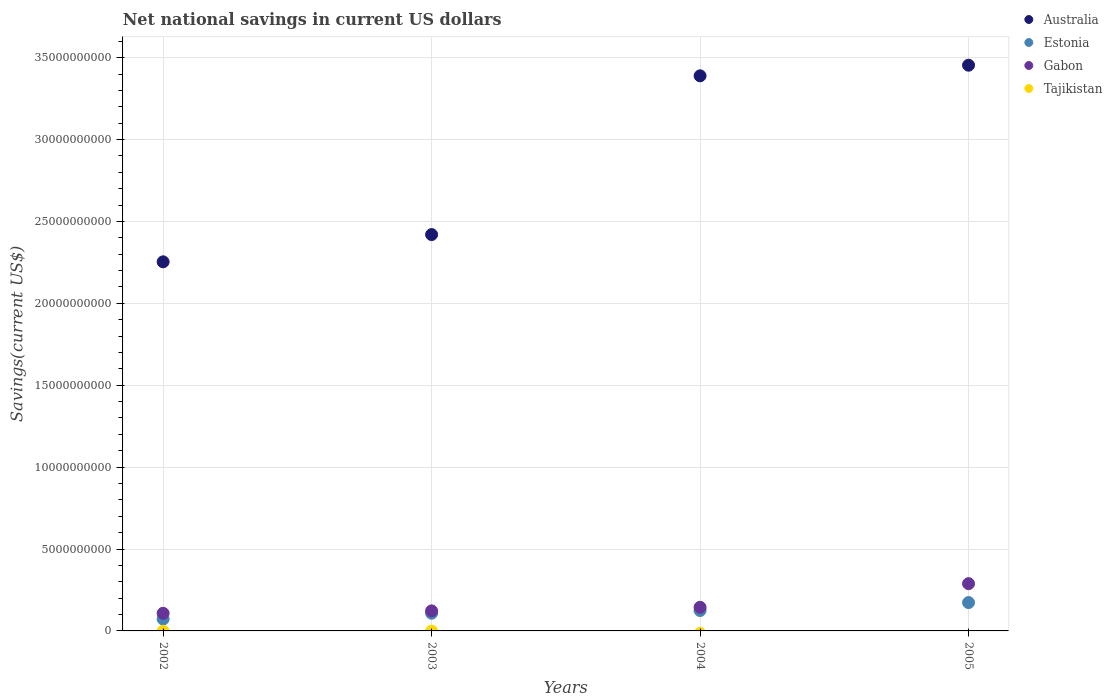Is the number of dotlines equal to the number of legend labels?
Provide a short and direct response. No. Across all years, what is the maximum net national savings in Australia?
Make the answer very short. 3.45e+1. Across all years, what is the minimum net national savings in Estonia?
Keep it short and to the point. 7.23e+08. In which year was the net national savings in Gabon maximum?
Ensure brevity in your answer.  2005. What is the total net national savings in Estonia in the graph?
Provide a succinct answer. 4.78e+09. What is the difference between the net national savings in Australia in 2002 and that in 2004?
Make the answer very short. -1.14e+1. What is the difference between the net national savings in Gabon in 2004 and the net national savings in Australia in 2003?
Your response must be concise. -2.28e+1. In the year 2002, what is the difference between the net national savings in Gabon and net national savings in Estonia?
Provide a short and direct response. 3.52e+08. What is the ratio of the net national savings in Gabon in 2003 to that in 2005?
Your answer should be very brief. 0.42. Is the net national savings in Gabon in 2002 less than that in 2003?
Offer a very short reply. Yes. Is the difference between the net national savings in Gabon in 2002 and 2004 greater than the difference between the net national savings in Estonia in 2002 and 2004?
Your answer should be compact. Yes. What is the difference between the highest and the second highest net national savings in Australia?
Provide a short and direct response. 6.49e+08. What is the difference between the highest and the lowest net national savings in Gabon?
Ensure brevity in your answer.  1.81e+09. Does the net national savings in Tajikistan monotonically increase over the years?
Give a very brief answer. No. Is the net national savings in Estonia strictly greater than the net national savings in Tajikistan over the years?
Your answer should be very brief. Yes. How many dotlines are there?
Give a very brief answer. 3. What is the difference between two consecutive major ticks on the Y-axis?
Your answer should be very brief. 5.00e+09. How many legend labels are there?
Your answer should be very brief. 4. What is the title of the graph?
Keep it short and to the point. Net national savings in current US dollars. What is the label or title of the X-axis?
Keep it short and to the point. Years. What is the label or title of the Y-axis?
Offer a terse response. Savings(current US$). What is the Savings(current US$) in Australia in 2002?
Make the answer very short. 2.25e+1. What is the Savings(current US$) of Estonia in 2002?
Make the answer very short. 7.23e+08. What is the Savings(current US$) of Gabon in 2002?
Provide a succinct answer. 1.08e+09. What is the Savings(current US$) in Tajikistan in 2002?
Offer a very short reply. 0. What is the Savings(current US$) in Australia in 2003?
Your answer should be very brief. 2.42e+1. What is the Savings(current US$) of Estonia in 2003?
Give a very brief answer. 1.08e+09. What is the Savings(current US$) of Gabon in 2003?
Make the answer very short. 1.22e+09. What is the Savings(current US$) of Australia in 2004?
Your response must be concise. 3.39e+1. What is the Savings(current US$) in Estonia in 2004?
Give a very brief answer. 1.25e+09. What is the Savings(current US$) of Gabon in 2004?
Give a very brief answer. 1.44e+09. What is the Savings(current US$) of Australia in 2005?
Provide a succinct answer. 3.45e+1. What is the Savings(current US$) in Estonia in 2005?
Offer a very short reply. 1.73e+09. What is the Savings(current US$) in Gabon in 2005?
Offer a terse response. 2.89e+09. What is the Savings(current US$) in Tajikistan in 2005?
Your answer should be compact. 0. Across all years, what is the maximum Savings(current US$) of Australia?
Keep it short and to the point. 3.45e+1. Across all years, what is the maximum Savings(current US$) in Estonia?
Your response must be concise. 1.73e+09. Across all years, what is the maximum Savings(current US$) of Gabon?
Offer a very short reply. 2.89e+09. Across all years, what is the minimum Savings(current US$) of Australia?
Make the answer very short. 2.25e+1. Across all years, what is the minimum Savings(current US$) of Estonia?
Provide a succinct answer. 7.23e+08. Across all years, what is the minimum Savings(current US$) in Gabon?
Ensure brevity in your answer.  1.08e+09. What is the total Savings(current US$) of Australia in the graph?
Provide a succinct answer. 1.15e+11. What is the total Savings(current US$) in Estonia in the graph?
Offer a very short reply. 4.78e+09. What is the total Savings(current US$) in Gabon in the graph?
Offer a terse response. 6.63e+09. What is the difference between the Savings(current US$) in Australia in 2002 and that in 2003?
Give a very brief answer. -1.66e+09. What is the difference between the Savings(current US$) of Estonia in 2002 and that in 2003?
Give a very brief answer. -3.56e+08. What is the difference between the Savings(current US$) of Gabon in 2002 and that in 2003?
Provide a succinct answer. -1.48e+08. What is the difference between the Savings(current US$) in Australia in 2002 and that in 2004?
Offer a very short reply. -1.14e+1. What is the difference between the Savings(current US$) of Estonia in 2002 and that in 2004?
Your answer should be very brief. -5.23e+08. What is the difference between the Savings(current US$) in Gabon in 2002 and that in 2004?
Ensure brevity in your answer.  -3.68e+08. What is the difference between the Savings(current US$) in Australia in 2002 and that in 2005?
Offer a very short reply. -1.20e+1. What is the difference between the Savings(current US$) of Estonia in 2002 and that in 2005?
Your response must be concise. -1.01e+09. What is the difference between the Savings(current US$) of Gabon in 2002 and that in 2005?
Your answer should be compact. -1.81e+09. What is the difference between the Savings(current US$) in Australia in 2003 and that in 2004?
Your answer should be compact. -9.69e+09. What is the difference between the Savings(current US$) of Estonia in 2003 and that in 2004?
Provide a succinct answer. -1.67e+08. What is the difference between the Savings(current US$) in Gabon in 2003 and that in 2004?
Your response must be concise. -2.20e+08. What is the difference between the Savings(current US$) in Australia in 2003 and that in 2005?
Provide a succinct answer. -1.03e+1. What is the difference between the Savings(current US$) of Estonia in 2003 and that in 2005?
Your answer should be compact. -6.51e+08. What is the difference between the Savings(current US$) of Gabon in 2003 and that in 2005?
Ensure brevity in your answer.  -1.66e+09. What is the difference between the Savings(current US$) of Australia in 2004 and that in 2005?
Provide a succinct answer. -6.49e+08. What is the difference between the Savings(current US$) of Estonia in 2004 and that in 2005?
Your answer should be very brief. -4.84e+08. What is the difference between the Savings(current US$) in Gabon in 2004 and that in 2005?
Your answer should be very brief. -1.44e+09. What is the difference between the Savings(current US$) in Australia in 2002 and the Savings(current US$) in Estonia in 2003?
Offer a very short reply. 2.15e+1. What is the difference between the Savings(current US$) in Australia in 2002 and the Savings(current US$) in Gabon in 2003?
Make the answer very short. 2.13e+1. What is the difference between the Savings(current US$) of Estonia in 2002 and the Savings(current US$) of Gabon in 2003?
Keep it short and to the point. -5.00e+08. What is the difference between the Savings(current US$) in Australia in 2002 and the Savings(current US$) in Estonia in 2004?
Offer a terse response. 2.13e+1. What is the difference between the Savings(current US$) in Australia in 2002 and the Savings(current US$) in Gabon in 2004?
Ensure brevity in your answer.  2.11e+1. What is the difference between the Savings(current US$) in Estonia in 2002 and the Savings(current US$) in Gabon in 2004?
Keep it short and to the point. -7.20e+08. What is the difference between the Savings(current US$) in Australia in 2002 and the Savings(current US$) in Estonia in 2005?
Ensure brevity in your answer.  2.08e+1. What is the difference between the Savings(current US$) of Australia in 2002 and the Savings(current US$) of Gabon in 2005?
Provide a succinct answer. 1.96e+1. What is the difference between the Savings(current US$) in Estonia in 2002 and the Savings(current US$) in Gabon in 2005?
Your answer should be very brief. -2.16e+09. What is the difference between the Savings(current US$) of Australia in 2003 and the Savings(current US$) of Estonia in 2004?
Give a very brief answer. 2.30e+1. What is the difference between the Savings(current US$) of Australia in 2003 and the Savings(current US$) of Gabon in 2004?
Provide a succinct answer. 2.28e+1. What is the difference between the Savings(current US$) in Estonia in 2003 and the Savings(current US$) in Gabon in 2004?
Offer a terse response. -3.64e+08. What is the difference between the Savings(current US$) in Australia in 2003 and the Savings(current US$) in Estonia in 2005?
Keep it short and to the point. 2.25e+1. What is the difference between the Savings(current US$) of Australia in 2003 and the Savings(current US$) of Gabon in 2005?
Offer a very short reply. 2.13e+1. What is the difference between the Savings(current US$) of Estonia in 2003 and the Savings(current US$) of Gabon in 2005?
Make the answer very short. -1.81e+09. What is the difference between the Savings(current US$) in Australia in 2004 and the Savings(current US$) in Estonia in 2005?
Keep it short and to the point. 3.22e+1. What is the difference between the Savings(current US$) in Australia in 2004 and the Savings(current US$) in Gabon in 2005?
Your answer should be very brief. 3.10e+1. What is the difference between the Savings(current US$) in Estonia in 2004 and the Savings(current US$) in Gabon in 2005?
Your answer should be compact. -1.64e+09. What is the average Savings(current US$) in Australia per year?
Your answer should be very brief. 2.88e+1. What is the average Savings(current US$) in Estonia per year?
Make the answer very short. 1.20e+09. What is the average Savings(current US$) in Gabon per year?
Make the answer very short. 1.66e+09. In the year 2002, what is the difference between the Savings(current US$) in Australia and Savings(current US$) in Estonia?
Offer a very short reply. 2.18e+1. In the year 2002, what is the difference between the Savings(current US$) of Australia and Savings(current US$) of Gabon?
Keep it short and to the point. 2.15e+1. In the year 2002, what is the difference between the Savings(current US$) of Estonia and Savings(current US$) of Gabon?
Ensure brevity in your answer.  -3.52e+08. In the year 2003, what is the difference between the Savings(current US$) in Australia and Savings(current US$) in Estonia?
Offer a very short reply. 2.31e+1. In the year 2003, what is the difference between the Savings(current US$) of Australia and Savings(current US$) of Gabon?
Your answer should be compact. 2.30e+1. In the year 2003, what is the difference between the Savings(current US$) in Estonia and Savings(current US$) in Gabon?
Ensure brevity in your answer.  -1.44e+08. In the year 2004, what is the difference between the Savings(current US$) in Australia and Savings(current US$) in Estonia?
Provide a short and direct response. 3.26e+1. In the year 2004, what is the difference between the Savings(current US$) in Australia and Savings(current US$) in Gabon?
Offer a terse response. 3.24e+1. In the year 2004, what is the difference between the Savings(current US$) in Estonia and Savings(current US$) in Gabon?
Offer a terse response. -1.97e+08. In the year 2005, what is the difference between the Savings(current US$) of Australia and Savings(current US$) of Estonia?
Offer a terse response. 3.28e+1. In the year 2005, what is the difference between the Savings(current US$) of Australia and Savings(current US$) of Gabon?
Provide a succinct answer. 3.17e+1. In the year 2005, what is the difference between the Savings(current US$) in Estonia and Savings(current US$) in Gabon?
Your response must be concise. -1.15e+09. What is the ratio of the Savings(current US$) in Australia in 2002 to that in 2003?
Provide a succinct answer. 0.93. What is the ratio of the Savings(current US$) in Estonia in 2002 to that in 2003?
Offer a terse response. 0.67. What is the ratio of the Savings(current US$) in Gabon in 2002 to that in 2003?
Ensure brevity in your answer.  0.88. What is the ratio of the Savings(current US$) in Australia in 2002 to that in 2004?
Provide a succinct answer. 0.66. What is the ratio of the Savings(current US$) of Estonia in 2002 to that in 2004?
Your answer should be very brief. 0.58. What is the ratio of the Savings(current US$) of Gabon in 2002 to that in 2004?
Provide a succinct answer. 0.75. What is the ratio of the Savings(current US$) of Australia in 2002 to that in 2005?
Provide a short and direct response. 0.65. What is the ratio of the Savings(current US$) in Estonia in 2002 to that in 2005?
Give a very brief answer. 0.42. What is the ratio of the Savings(current US$) in Gabon in 2002 to that in 2005?
Ensure brevity in your answer.  0.37. What is the ratio of the Savings(current US$) in Australia in 2003 to that in 2004?
Your answer should be compact. 0.71. What is the ratio of the Savings(current US$) in Estonia in 2003 to that in 2004?
Your answer should be very brief. 0.87. What is the ratio of the Savings(current US$) of Gabon in 2003 to that in 2004?
Ensure brevity in your answer.  0.85. What is the ratio of the Savings(current US$) of Australia in 2003 to that in 2005?
Keep it short and to the point. 0.7. What is the ratio of the Savings(current US$) of Estonia in 2003 to that in 2005?
Offer a terse response. 0.62. What is the ratio of the Savings(current US$) in Gabon in 2003 to that in 2005?
Keep it short and to the point. 0.42. What is the ratio of the Savings(current US$) in Australia in 2004 to that in 2005?
Make the answer very short. 0.98. What is the ratio of the Savings(current US$) in Estonia in 2004 to that in 2005?
Give a very brief answer. 0.72. What is the ratio of the Savings(current US$) in Gabon in 2004 to that in 2005?
Keep it short and to the point. 0.5. What is the difference between the highest and the second highest Savings(current US$) in Australia?
Offer a very short reply. 6.49e+08. What is the difference between the highest and the second highest Savings(current US$) of Estonia?
Offer a terse response. 4.84e+08. What is the difference between the highest and the second highest Savings(current US$) in Gabon?
Offer a terse response. 1.44e+09. What is the difference between the highest and the lowest Savings(current US$) in Australia?
Provide a succinct answer. 1.20e+1. What is the difference between the highest and the lowest Savings(current US$) in Estonia?
Your response must be concise. 1.01e+09. What is the difference between the highest and the lowest Savings(current US$) of Gabon?
Provide a succinct answer. 1.81e+09. 